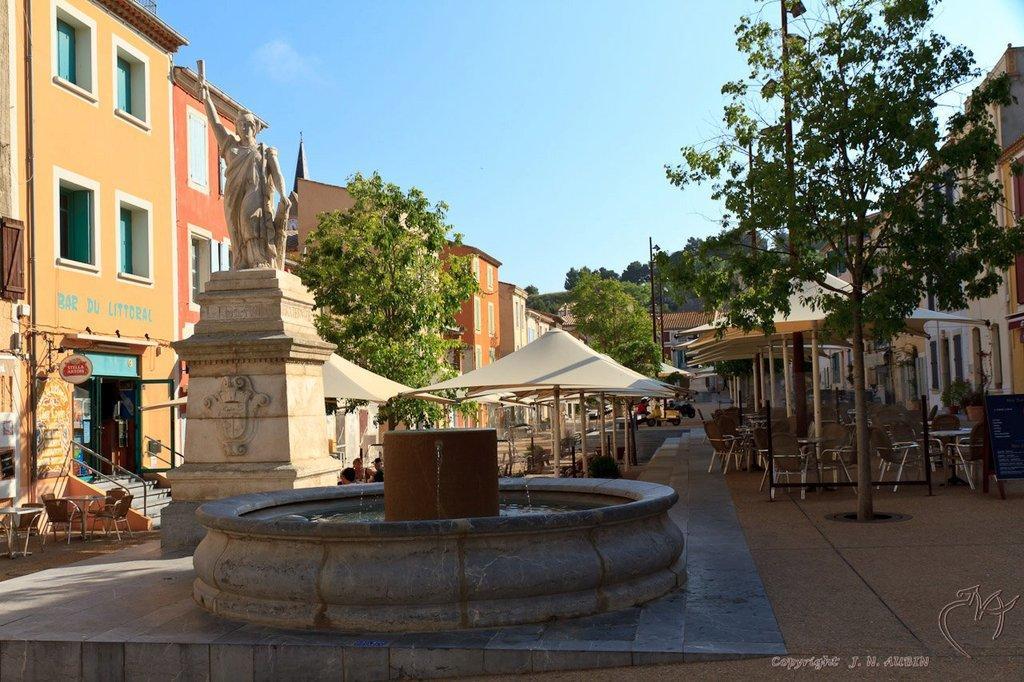Please provide a concise description of this image. In this picture we can observe statue which in white color. We can observe some water here. There are some trees. There are some buildings on either sides of the picture. We can observe some chairs. We can observe that there is a sky. 